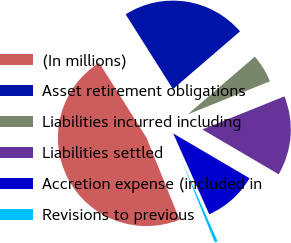Convert chart. <chart><loc_0><loc_0><loc_500><loc_500><pie_chart><fcel>(In millions)<fcel>Asset retirement obligations<fcel>Liabilities incurred including<fcel>Liabilities settled<fcel>Accretion expense (included in<fcel>Revisions to previous<nl><fcel>47.14%<fcel>22.66%<fcel>5.22%<fcel>14.54%<fcel>9.88%<fcel>0.56%<nl></chart> 